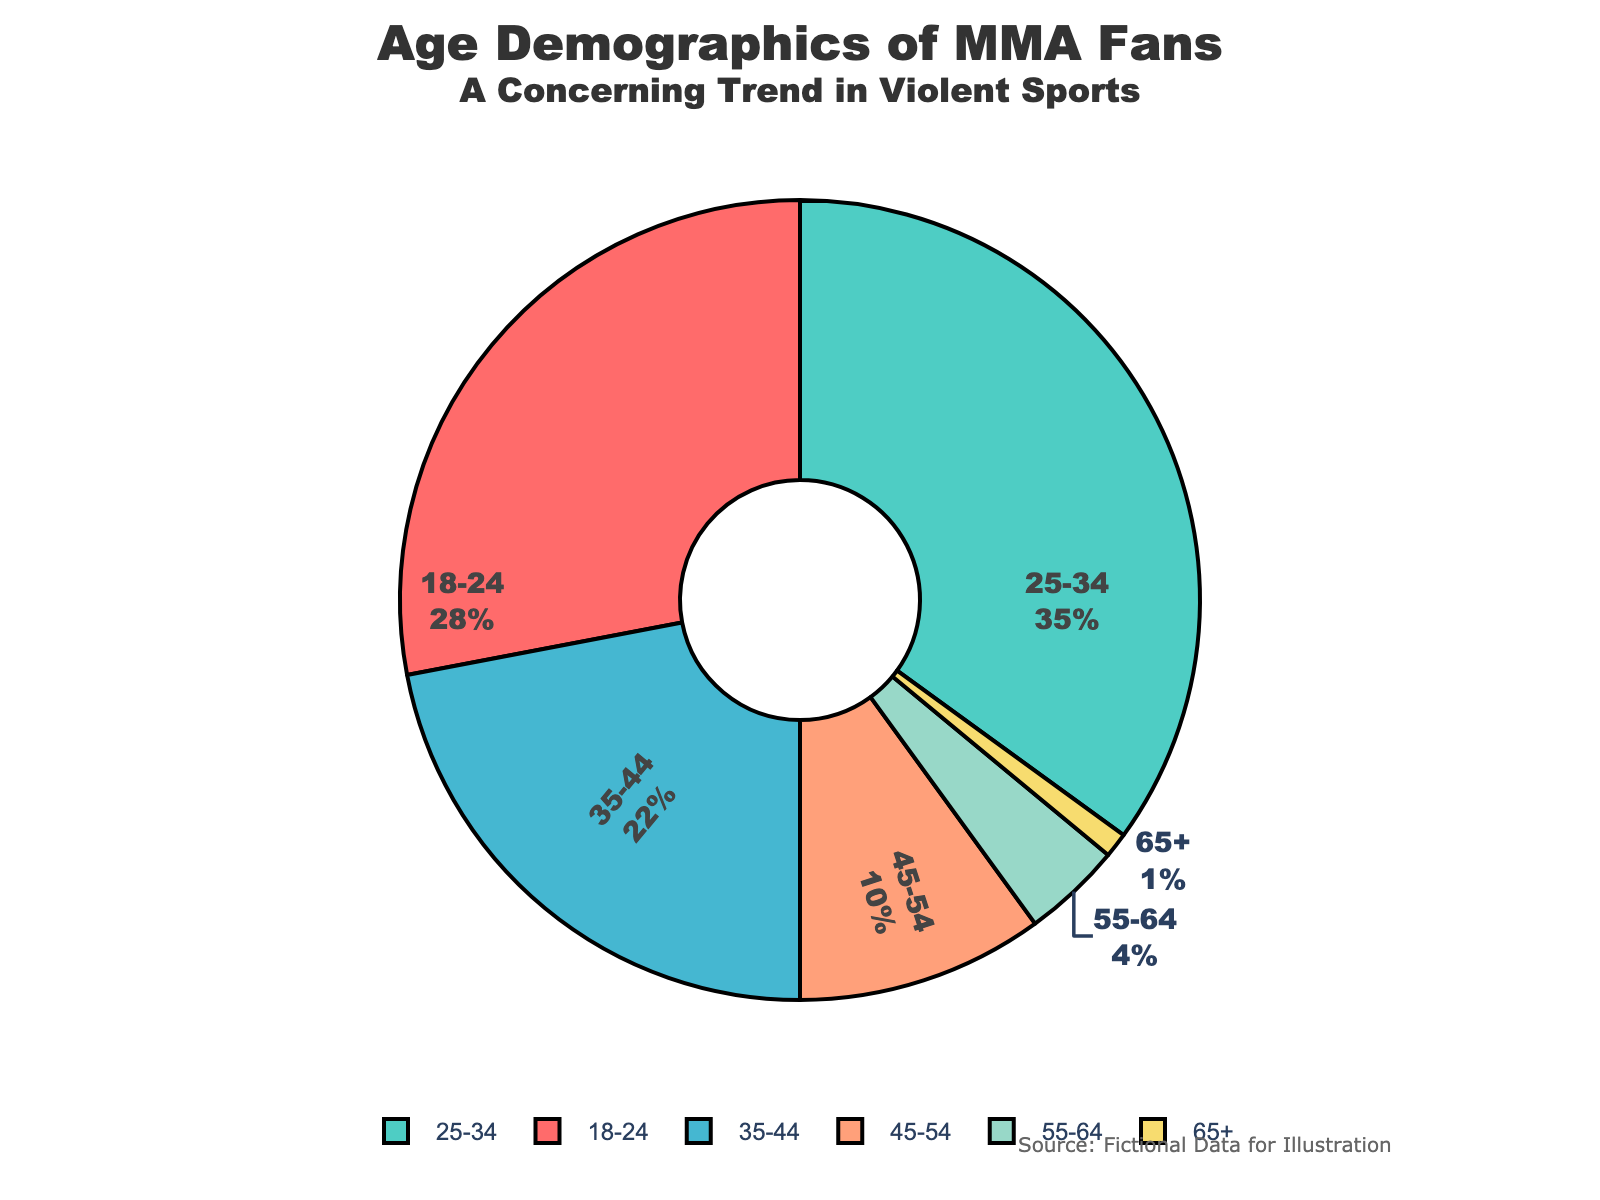What percentage of MMA fans are aged 35-44? The pie chart shows the percentages of different age groups among MMA fans. We can directly look at the segment labeled "35-44" to find the percentage.
Answer: 22% Which age group has the lowest percentage of MMA fans? We need to compare the percentages of all age groups. The age group with the smallest segment and percentage is "65+"
Answer: 65+ How many age groups have more than 20% of MMA fans? Check each age group's percentage and count how many are over 20%. Age groups 18-24 (28%), 25-34 (35%), and 35-44 (22%) are all over 20%.
Answer: 3 What is the combined percentage of MMA fans aged 25-34 and 35-44? Add the percentages of the 25-34 group (35%) and the 35-44 group (22%). 35 + 22 = 57%
Answer: 57% Which age group has the largest fan base, and what is their percentage? Identify the segment of the pie chart with the largest percentage. The 25-34 age group holds the largest segment.
Answer: 25-34, 35% Is the percentage of MMA fans aged 45-54 greater than the percentage of fans aged 55-64? Compare the percentages of the 45-54 group (10%) and the 55-64 group (4%).
Answer: Yes, 10% > 4% Which age group is depicted with the yellow color in the chart? Identify the yellow segment from the pie chart, which is the slice corresponding to the age group 55-64.
Answer: 55-64 What percent of MMA fans are aged 55 or older? Add the percentages of the 55-64 group (4%) and the 65+ group (1%). 4 + 1 = 5%
Answer: 5% How much more percentage of MMA fans are aged 18-24 compared to those aged 65+? Subtract the percentage of the 65+ group (1%) from that of the 18-24 group (28%). 28 - 1 = 27%
Answer: 27% Is the sum of the percentages of fans aged 18-24 and 45-54 less than 50%? Add the percentages of the 18-24 group (28%) and the 45-54 group (10%). 28 + 10 = 38%, which is less than 50%.
Answer: Yes, 38% < 50% 